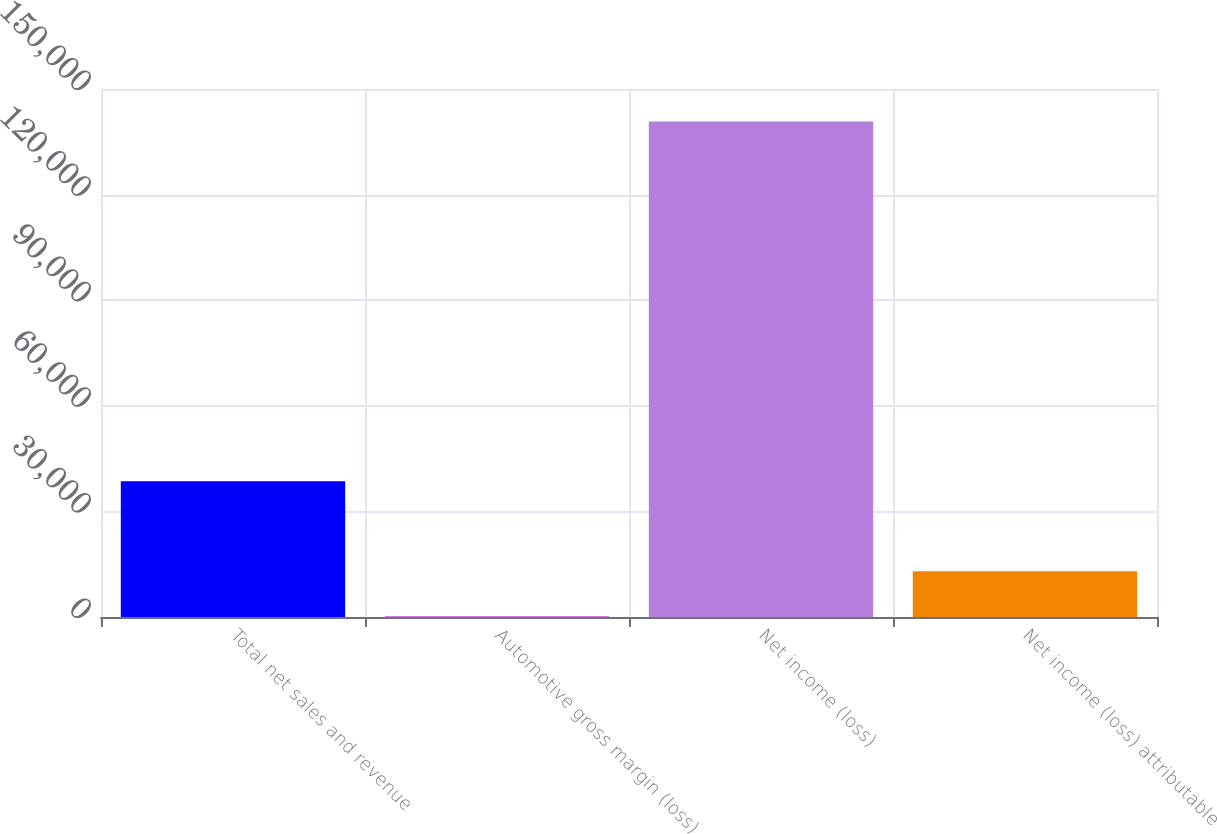<chart> <loc_0><loc_0><loc_500><loc_500><bar_chart><fcel>Total net sales and revenue<fcel>Automotive gross margin (loss)<fcel>Net income (loss)<fcel>Net income (loss) attributable<nl><fcel>38569.1<fcel>182<fcel>140794<fcel>12977.7<nl></chart> 